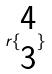<formula> <loc_0><loc_0><loc_500><loc_500>r \{ \begin{matrix} 4 \\ 3 \end{matrix} \}</formula> 